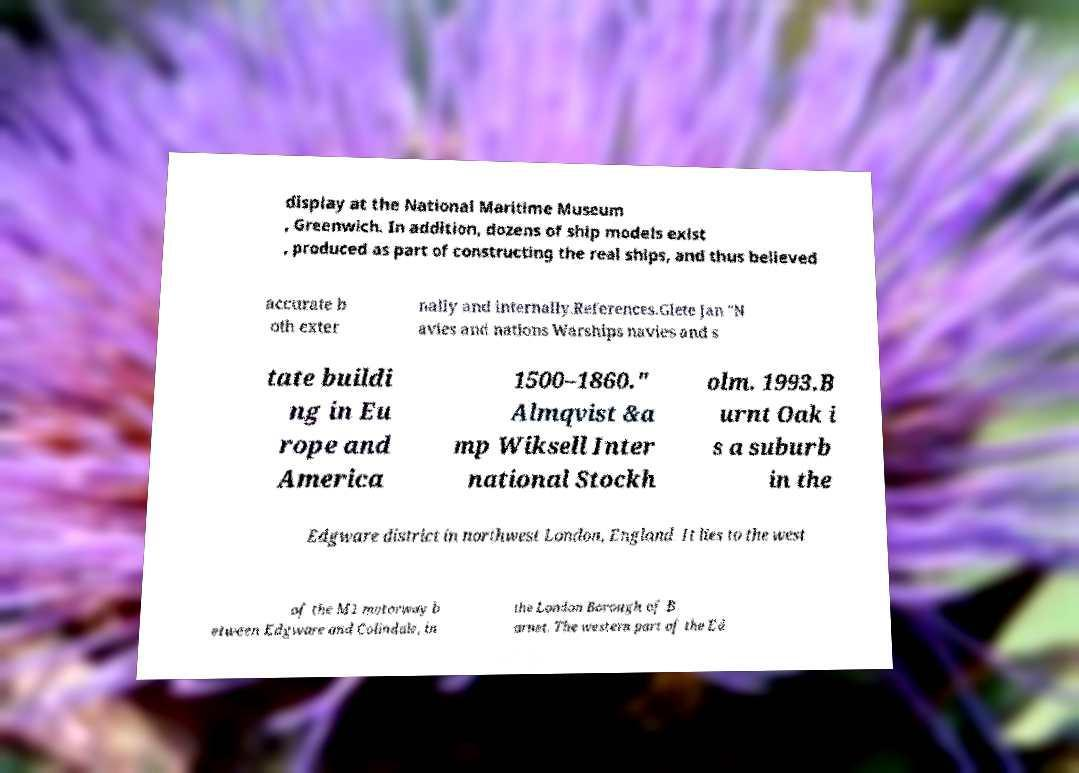Could you assist in decoding the text presented in this image and type it out clearly? display at the National Maritime Museum , Greenwich. In addition, dozens of ship models exist , produced as part of constructing the real ships, and thus believed accurate b oth exter nally and internally.References.Glete Jan "N avies and nations Warships navies and s tate buildi ng in Eu rope and America 1500–1860." Almqvist &a mp Wiksell Inter national Stockh olm. 1993.B urnt Oak i s a suburb in the Edgware district in northwest London, England. It lies to the west of the M1 motorway b etween Edgware and Colindale, in the London Borough of B arnet. The western part of the Ed 